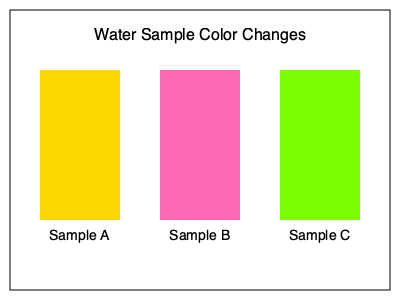Based on the color changes observed in the water samples after testing, which sample is most likely contaminated with lead? To identify the contaminant based on color changes, we need to consider the typical reactions of water quality test kits:

1. Sample A (Yellow): This color is often associated with the presence of chlorine or high pH levels. It's not typically indicative of lead contamination.

2. Sample B (Pink): A pink or reddish color is commonly associated with the presence of lead in water quality tests. Many lead testing kits use reagents that turn pink or red in the presence of lead ions.

3. Sample C (Green): Green coloration in water tests is often associated with copper contamination or sometimes with certain types of algae. It's not typically linked to lead presence.

Given this information, the sample most likely to be contaminated with lead is Sample B, which shows a pink coloration.
Answer: Sample B 